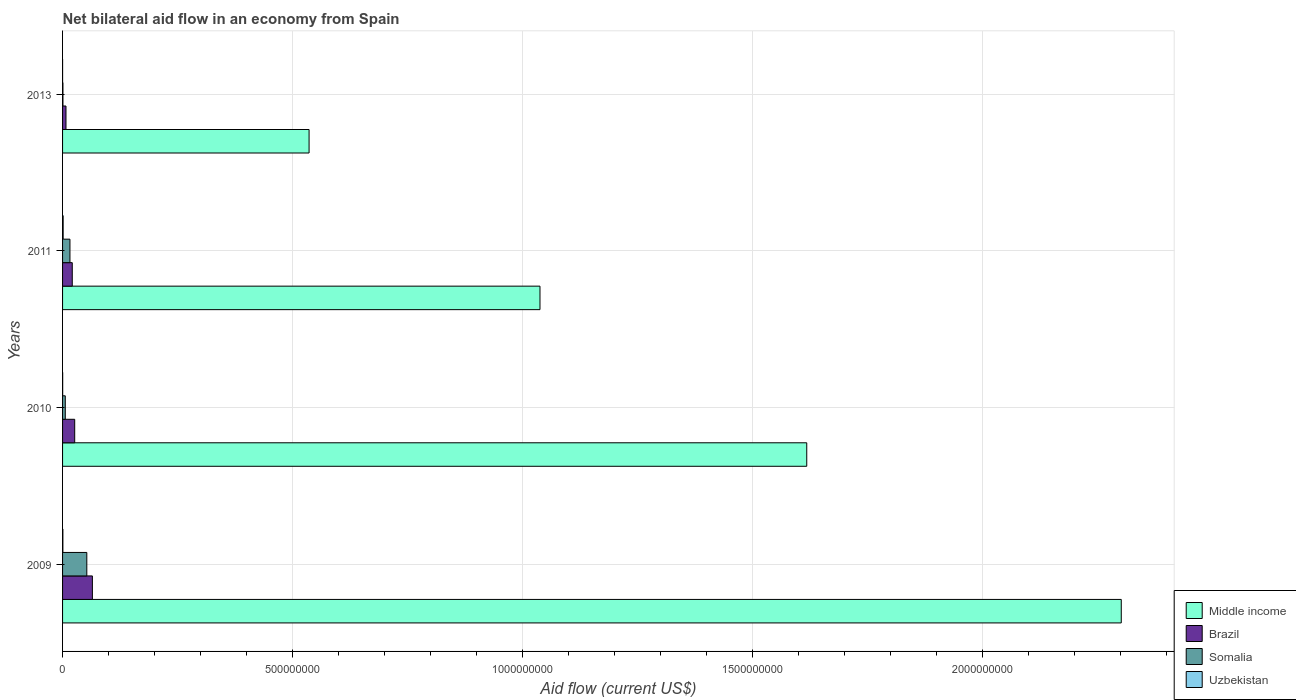How many bars are there on the 3rd tick from the top?
Your answer should be compact. 4. What is the net bilateral aid flow in Middle income in 2009?
Give a very brief answer. 2.30e+09. Across all years, what is the maximum net bilateral aid flow in Uzbekistan?
Offer a very short reply. 1.27e+06. Across all years, what is the minimum net bilateral aid flow in Brazil?
Offer a very short reply. 7.44e+06. In which year was the net bilateral aid flow in Uzbekistan maximum?
Provide a succinct answer. 2011. What is the total net bilateral aid flow in Uzbekistan in the graph?
Offer a terse response. 2.19e+06. What is the difference between the net bilateral aid flow in Middle income in 2009 and that in 2010?
Give a very brief answer. 6.84e+08. What is the difference between the net bilateral aid flow in Somalia in 2010 and the net bilateral aid flow in Brazil in 2009?
Offer a very short reply. -5.90e+07. What is the average net bilateral aid flow in Somalia per year?
Offer a terse response. 1.89e+07. In the year 2011, what is the difference between the net bilateral aid flow in Uzbekistan and net bilateral aid flow in Somalia?
Provide a short and direct response. -1.48e+07. In how many years, is the net bilateral aid flow in Brazil greater than 2000000000 US$?
Your answer should be very brief. 0. What is the ratio of the net bilateral aid flow in Middle income in 2009 to that in 2013?
Your response must be concise. 4.29. What is the difference between the highest and the second highest net bilateral aid flow in Somalia?
Offer a terse response. 3.67e+07. What is the difference between the highest and the lowest net bilateral aid flow in Brazil?
Make the answer very short. 5.74e+07. In how many years, is the net bilateral aid flow in Somalia greater than the average net bilateral aid flow in Somalia taken over all years?
Make the answer very short. 1. Is the sum of the net bilateral aid flow in Somalia in 2011 and 2013 greater than the maximum net bilateral aid flow in Middle income across all years?
Ensure brevity in your answer.  No. Is it the case that in every year, the sum of the net bilateral aid flow in Brazil and net bilateral aid flow in Middle income is greater than the sum of net bilateral aid flow in Uzbekistan and net bilateral aid flow in Somalia?
Offer a terse response. Yes. What does the 3rd bar from the bottom in 2013 represents?
Your answer should be very brief. Somalia. Is it the case that in every year, the sum of the net bilateral aid flow in Somalia and net bilateral aid flow in Uzbekistan is greater than the net bilateral aid flow in Brazil?
Offer a very short reply. No. Are all the bars in the graph horizontal?
Give a very brief answer. Yes. What is the difference between two consecutive major ticks on the X-axis?
Your answer should be very brief. 5.00e+08. Are the values on the major ticks of X-axis written in scientific E-notation?
Provide a succinct answer. No. Does the graph contain any zero values?
Make the answer very short. No. How many legend labels are there?
Your answer should be very brief. 4. How are the legend labels stacked?
Your response must be concise. Vertical. What is the title of the graph?
Offer a very short reply. Net bilateral aid flow in an economy from Spain. What is the label or title of the X-axis?
Your answer should be very brief. Aid flow (current US$). What is the label or title of the Y-axis?
Your response must be concise. Years. What is the Aid flow (current US$) of Middle income in 2009?
Your answer should be compact. 2.30e+09. What is the Aid flow (current US$) in Brazil in 2009?
Your answer should be very brief. 6.49e+07. What is the Aid flow (current US$) in Somalia in 2009?
Offer a very short reply. 5.28e+07. What is the Aid flow (current US$) of Middle income in 2010?
Your answer should be very brief. 1.62e+09. What is the Aid flow (current US$) of Brazil in 2010?
Give a very brief answer. 2.64e+07. What is the Aid flow (current US$) in Somalia in 2010?
Make the answer very short. 5.89e+06. What is the Aid flow (current US$) in Middle income in 2011?
Offer a terse response. 1.04e+09. What is the Aid flow (current US$) of Brazil in 2011?
Your response must be concise. 2.11e+07. What is the Aid flow (current US$) of Somalia in 2011?
Offer a very short reply. 1.60e+07. What is the Aid flow (current US$) of Uzbekistan in 2011?
Your answer should be compact. 1.27e+06. What is the Aid flow (current US$) of Middle income in 2013?
Provide a short and direct response. 5.36e+08. What is the Aid flow (current US$) in Brazil in 2013?
Offer a terse response. 7.44e+06. What is the Aid flow (current US$) of Somalia in 2013?
Keep it short and to the point. 8.10e+05. Across all years, what is the maximum Aid flow (current US$) in Middle income?
Give a very brief answer. 2.30e+09. Across all years, what is the maximum Aid flow (current US$) of Brazil?
Your answer should be compact. 6.49e+07. Across all years, what is the maximum Aid flow (current US$) in Somalia?
Provide a succinct answer. 5.28e+07. Across all years, what is the maximum Aid flow (current US$) of Uzbekistan?
Provide a succinct answer. 1.27e+06. Across all years, what is the minimum Aid flow (current US$) of Middle income?
Make the answer very short. 5.36e+08. Across all years, what is the minimum Aid flow (current US$) of Brazil?
Ensure brevity in your answer.  7.44e+06. Across all years, what is the minimum Aid flow (current US$) of Somalia?
Your response must be concise. 8.10e+05. Across all years, what is the minimum Aid flow (current US$) of Uzbekistan?
Ensure brevity in your answer.  3.00e+04. What is the total Aid flow (current US$) in Middle income in the graph?
Make the answer very short. 5.50e+09. What is the total Aid flow (current US$) of Brazil in the graph?
Keep it short and to the point. 1.20e+08. What is the total Aid flow (current US$) in Somalia in the graph?
Ensure brevity in your answer.  7.55e+07. What is the total Aid flow (current US$) in Uzbekistan in the graph?
Provide a short and direct response. 2.19e+06. What is the difference between the Aid flow (current US$) of Middle income in 2009 and that in 2010?
Make the answer very short. 6.84e+08. What is the difference between the Aid flow (current US$) in Brazil in 2009 and that in 2010?
Keep it short and to the point. 3.85e+07. What is the difference between the Aid flow (current US$) in Somalia in 2009 and that in 2010?
Your answer should be compact. 4.69e+07. What is the difference between the Aid flow (current US$) in Middle income in 2009 and that in 2011?
Give a very brief answer. 1.26e+09. What is the difference between the Aid flow (current US$) in Brazil in 2009 and that in 2011?
Make the answer very short. 4.38e+07. What is the difference between the Aid flow (current US$) of Somalia in 2009 and that in 2011?
Offer a terse response. 3.67e+07. What is the difference between the Aid flow (current US$) of Uzbekistan in 2009 and that in 2011?
Provide a short and direct response. -6.10e+05. What is the difference between the Aid flow (current US$) in Middle income in 2009 and that in 2013?
Offer a very short reply. 1.77e+09. What is the difference between the Aid flow (current US$) of Brazil in 2009 and that in 2013?
Ensure brevity in your answer.  5.74e+07. What is the difference between the Aid flow (current US$) of Somalia in 2009 and that in 2013?
Your response must be concise. 5.19e+07. What is the difference between the Aid flow (current US$) in Uzbekistan in 2009 and that in 2013?
Offer a very short reply. 6.30e+05. What is the difference between the Aid flow (current US$) of Middle income in 2010 and that in 2011?
Your response must be concise. 5.80e+08. What is the difference between the Aid flow (current US$) of Brazil in 2010 and that in 2011?
Offer a terse response. 5.29e+06. What is the difference between the Aid flow (current US$) of Somalia in 2010 and that in 2011?
Provide a succinct answer. -1.02e+07. What is the difference between the Aid flow (current US$) of Uzbekistan in 2010 and that in 2011?
Offer a terse response. -1.04e+06. What is the difference between the Aid flow (current US$) in Middle income in 2010 and that in 2013?
Ensure brevity in your answer.  1.08e+09. What is the difference between the Aid flow (current US$) in Brazil in 2010 and that in 2013?
Ensure brevity in your answer.  1.90e+07. What is the difference between the Aid flow (current US$) of Somalia in 2010 and that in 2013?
Make the answer very short. 5.08e+06. What is the difference between the Aid flow (current US$) of Middle income in 2011 and that in 2013?
Offer a terse response. 5.02e+08. What is the difference between the Aid flow (current US$) in Brazil in 2011 and that in 2013?
Your response must be concise. 1.37e+07. What is the difference between the Aid flow (current US$) in Somalia in 2011 and that in 2013?
Your answer should be compact. 1.52e+07. What is the difference between the Aid flow (current US$) of Uzbekistan in 2011 and that in 2013?
Your answer should be very brief. 1.24e+06. What is the difference between the Aid flow (current US$) of Middle income in 2009 and the Aid flow (current US$) of Brazil in 2010?
Offer a terse response. 2.28e+09. What is the difference between the Aid flow (current US$) in Middle income in 2009 and the Aid flow (current US$) in Somalia in 2010?
Your response must be concise. 2.30e+09. What is the difference between the Aid flow (current US$) in Middle income in 2009 and the Aid flow (current US$) in Uzbekistan in 2010?
Make the answer very short. 2.30e+09. What is the difference between the Aid flow (current US$) in Brazil in 2009 and the Aid flow (current US$) in Somalia in 2010?
Provide a short and direct response. 5.90e+07. What is the difference between the Aid flow (current US$) in Brazil in 2009 and the Aid flow (current US$) in Uzbekistan in 2010?
Your response must be concise. 6.46e+07. What is the difference between the Aid flow (current US$) in Somalia in 2009 and the Aid flow (current US$) in Uzbekistan in 2010?
Make the answer very short. 5.25e+07. What is the difference between the Aid flow (current US$) in Middle income in 2009 and the Aid flow (current US$) in Brazil in 2011?
Provide a succinct answer. 2.28e+09. What is the difference between the Aid flow (current US$) of Middle income in 2009 and the Aid flow (current US$) of Somalia in 2011?
Provide a succinct answer. 2.29e+09. What is the difference between the Aid flow (current US$) in Middle income in 2009 and the Aid flow (current US$) in Uzbekistan in 2011?
Offer a terse response. 2.30e+09. What is the difference between the Aid flow (current US$) in Brazil in 2009 and the Aid flow (current US$) in Somalia in 2011?
Offer a very short reply. 4.88e+07. What is the difference between the Aid flow (current US$) of Brazil in 2009 and the Aid flow (current US$) of Uzbekistan in 2011?
Your answer should be very brief. 6.36e+07. What is the difference between the Aid flow (current US$) in Somalia in 2009 and the Aid flow (current US$) in Uzbekistan in 2011?
Offer a very short reply. 5.15e+07. What is the difference between the Aid flow (current US$) of Middle income in 2009 and the Aid flow (current US$) of Brazil in 2013?
Provide a succinct answer. 2.30e+09. What is the difference between the Aid flow (current US$) in Middle income in 2009 and the Aid flow (current US$) in Somalia in 2013?
Your response must be concise. 2.30e+09. What is the difference between the Aid flow (current US$) of Middle income in 2009 and the Aid flow (current US$) of Uzbekistan in 2013?
Give a very brief answer. 2.30e+09. What is the difference between the Aid flow (current US$) in Brazil in 2009 and the Aid flow (current US$) in Somalia in 2013?
Keep it short and to the point. 6.41e+07. What is the difference between the Aid flow (current US$) of Brazil in 2009 and the Aid flow (current US$) of Uzbekistan in 2013?
Make the answer very short. 6.48e+07. What is the difference between the Aid flow (current US$) of Somalia in 2009 and the Aid flow (current US$) of Uzbekistan in 2013?
Provide a short and direct response. 5.27e+07. What is the difference between the Aid flow (current US$) in Middle income in 2010 and the Aid flow (current US$) in Brazil in 2011?
Your answer should be very brief. 1.60e+09. What is the difference between the Aid flow (current US$) of Middle income in 2010 and the Aid flow (current US$) of Somalia in 2011?
Your answer should be very brief. 1.60e+09. What is the difference between the Aid flow (current US$) in Middle income in 2010 and the Aid flow (current US$) in Uzbekistan in 2011?
Provide a short and direct response. 1.62e+09. What is the difference between the Aid flow (current US$) in Brazil in 2010 and the Aid flow (current US$) in Somalia in 2011?
Give a very brief answer. 1.03e+07. What is the difference between the Aid flow (current US$) in Brazil in 2010 and the Aid flow (current US$) in Uzbekistan in 2011?
Keep it short and to the point. 2.51e+07. What is the difference between the Aid flow (current US$) of Somalia in 2010 and the Aid flow (current US$) of Uzbekistan in 2011?
Your response must be concise. 4.62e+06. What is the difference between the Aid flow (current US$) of Middle income in 2010 and the Aid flow (current US$) of Brazil in 2013?
Ensure brevity in your answer.  1.61e+09. What is the difference between the Aid flow (current US$) of Middle income in 2010 and the Aid flow (current US$) of Somalia in 2013?
Ensure brevity in your answer.  1.62e+09. What is the difference between the Aid flow (current US$) in Middle income in 2010 and the Aid flow (current US$) in Uzbekistan in 2013?
Provide a succinct answer. 1.62e+09. What is the difference between the Aid flow (current US$) of Brazil in 2010 and the Aid flow (current US$) of Somalia in 2013?
Provide a succinct answer. 2.56e+07. What is the difference between the Aid flow (current US$) in Brazil in 2010 and the Aid flow (current US$) in Uzbekistan in 2013?
Your answer should be very brief. 2.64e+07. What is the difference between the Aid flow (current US$) of Somalia in 2010 and the Aid flow (current US$) of Uzbekistan in 2013?
Give a very brief answer. 5.86e+06. What is the difference between the Aid flow (current US$) in Middle income in 2011 and the Aid flow (current US$) in Brazil in 2013?
Keep it short and to the point. 1.03e+09. What is the difference between the Aid flow (current US$) of Middle income in 2011 and the Aid flow (current US$) of Somalia in 2013?
Your answer should be very brief. 1.04e+09. What is the difference between the Aid flow (current US$) of Middle income in 2011 and the Aid flow (current US$) of Uzbekistan in 2013?
Your answer should be compact. 1.04e+09. What is the difference between the Aid flow (current US$) of Brazil in 2011 and the Aid flow (current US$) of Somalia in 2013?
Ensure brevity in your answer.  2.03e+07. What is the difference between the Aid flow (current US$) of Brazil in 2011 and the Aid flow (current US$) of Uzbekistan in 2013?
Your answer should be compact. 2.11e+07. What is the difference between the Aid flow (current US$) in Somalia in 2011 and the Aid flow (current US$) in Uzbekistan in 2013?
Provide a short and direct response. 1.60e+07. What is the average Aid flow (current US$) in Middle income per year?
Provide a succinct answer. 1.37e+09. What is the average Aid flow (current US$) of Brazil per year?
Your answer should be compact. 3.00e+07. What is the average Aid flow (current US$) of Somalia per year?
Ensure brevity in your answer.  1.89e+07. What is the average Aid flow (current US$) of Uzbekistan per year?
Provide a short and direct response. 5.48e+05. In the year 2009, what is the difference between the Aid flow (current US$) of Middle income and Aid flow (current US$) of Brazil?
Give a very brief answer. 2.24e+09. In the year 2009, what is the difference between the Aid flow (current US$) of Middle income and Aid flow (current US$) of Somalia?
Give a very brief answer. 2.25e+09. In the year 2009, what is the difference between the Aid flow (current US$) in Middle income and Aid flow (current US$) in Uzbekistan?
Make the answer very short. 2.30e+09. In the year 2009, what is the difference between the Aid flow (current US$) in Brazil and Aid flow (current US$) in Somalia?
Offer a very short reply. 1.21e+07. In the year 2009, what is the difference between the Aid flow (current US$) in Brazil and Aid flow (current US$) in Uzbekistan?
Your answer should be compact. 6.42e+07. In the year 2009, what is the difference between the Aid flow (current US$) of Somalia and Aid flow (current US$) of Uzbekistan?
Your answer should be compact. 5.21e+07. In the year 2010, what is the difference between the Aid flow (current US$) in Middle income and Aid flow (current US$) in Brazil?
Your answer should be compact. 1.59e+09. In the year 2010, what is the difference between the Aid flow (current US$) in Middle income and Aid flow (current US$) in Somalia?
Give a very brief answer. 1.61e+09. In the year 2010, what is the difference between the Aid flow (current US$) in Middle income and Aid flow (current US$) in Uzbekistan?
Ensure brevity in your answer.  1.62e+09. In the year 2010, what is the difference between the Aid flow (current US$) of Brazil and Aid flow (current US$) of Somalia?
Give a very brief answer. 2.05e+07. In the year 2010, what is the difference between the Aid flow (current US$) of Brazil and Aid flow (current US$) of Uzbekistan?
Your answer should be compact. 2.62e+07. In the year 2010, what is the difference between the Aid flow (current US$) in Somalia and Aid flow (current US$) in Uzbekistan?
Your answer should be compact. 5.66e+06. In the year 2011, what is the difference between the Aid flow (current US$) of Middle income and Aid flow (current US$) of Brazil?
Your response must be concise. 1.02e+09. In the year 2011, what is the difference between the Aid flow (current US$) in Middle income and Aid flow (current US$) in Somalia?
Make the answer very short. 1.02e+09. In the year 2011, what is the difference between the Aid flow (current US$) of Middle income and Aid flow (current US$) of Uzbekistan?
Offer a very short reply. 1.04e+09. In the year 2011, what is the difference between the Aid flow (current US$) of Brazil and Aid flow (current US$) of Somalia?
Provide a short and direct response. 5.05e+06. In the year 2011, what is the difference between the Aid flow (current US$) of Brazil and Aid flow (current US$) of Uzbekistan?
Provide a succinct answer. 1.98e+07. In the year 2011, what is the difference between the Aid flow (current US$) in Somalia and Aid flow (current US$) in Uzbekistan?
Provide a succinct answer. 1.48e+07. In the year 2013, what is the difference between the Aid flow (current US$) of Middle income and Aid flow (current US$) of Brazil?
Give a very brief answer. 5.29e+08. In the year 2013, what is the difference between the Aid flow (current US$) of Middle income and Aid flow (current US$) of Somalia?
Provide a short and direct response. 5.35e+08. In the year 2013, what is the difference between the Aid flow (current US$) of Middle income and Aid flow (current US$) of Uzbekistan?
Ensure brevity in your answer.  5.36e+08. In the year 2013, what is the difference between the Aid flow (current US$) of Brazil and Aid flow (current US$) of Somalia?
Give a very brief answer. 6.63e+06. In the year 2013, what is the difference between the Aid flow (current US$) of Brazil and Aid flow (current US$) of Uzbekistan?
Keep it short and to the point. 7.41e+06. In the year 2013, what is the difference between the Aid flow (current US$) of Somalia and Aid flow (current US$) of Uzbekistan?
Offer a very short reply. 7.80e+05. What is the ratio of the Aid flow (current US$) in Middle income in 2009 to that in 2010?
Offer a very short reply. 1.42. What is the ratio of the Aid flow (current US$) in Brazil in 2009 to that in 2010?
Keep it short and to the point. 2.46. What is the ratio of the Aid flow (current US$) of Somalia in 2009 to that in 2010?
Provide a succinct answer. 8.96. What is the ratio of the Aid flow (current US$) of Uzbekistan in 2009 to that in 2010?
Give a very brief answer. 2.87. What is the ratio of the Aid flow (current US$) of Middle income in 2009 to that in 2011?
Give a very brief answer. 2.22. What is the ratio of the Aid flow (current US$) in Brazil in 2009 to that in 2011?
Ensure brevity in your answer.  3.07. What is the ratio of the Aid flow (current US$) of Somalia in 2009 to that in 2011?
Your response must be concise. 3.29. What is the ratio of the Aid flow (current US$) of Uzbekistan in 2009 to that in 2011?
Your answer should be compact. 0.52. What is the ratio of the Aid flow (current US$) in Middle income in 2009 to that in 2013?
Your answer should be very brief. 4.29. What is the ratio of the Aid flow (current US$) in Brazil in 2009 to that in 2013?
Make the answer very short. 8.72. What is the ratio of the Aid flow (current US$) in Somalia in 2009 to that in 2013?
Keep it short and to the point. 65.12. What is the ratio of the Aid flow (current US$) of Uzbekistan in 2009 to that in 2013?
Offer a terse response. 22. What is the ratio of the Aid flow (current US$) of Middle income in 2010 to that in 2011?
Give a very brief answer. 1.56. What is the ratio of the Aid flow (current US$) of Brazil in 2010 to that in 2011?
Your answer should be compact. 1.25. What is the ratio of the Aid flow (current US$) in Somalia in 2010 to that in 2011?
Give a very brief answer. 0.37. What is the ratio of the Aid flow (current US$) of Uzbekistan in 2010 to that in 2011?
Give a very brief answer. 0.18. What is the ratio of the Aid flow (current US$) of Middle income in 2010 to that in 2013?
Offer a very short reply. 3.02. What is the ratio of the Aid flow (current US$) in Brazil in 2010 to that in 2013?
Give a very brief answer. 3.55. What is the ratio of the Aid flow (current US$) of Somalia in 2010 to that in 2013?
Offer a terse response. 7.27. What is the ratio of the Aid flow (current US$) of Uzbekistan in 2010 to that in 2013?
Offer a terse response. 7.67. What is the ratio of the Aid flow (current US$) in Middle income in 2011 to that in 2013?
Your answer should be very brief. 1.94. What is the ratio of the Aid flow (current US$) of Brazil in 2011 to that in 2013?
Give a very brief answer. 2.84. What is the ratio of the Aid flow (current US$) in Somalia in 2011 to that in 2013?
Provide a succinct answer. 19.81. What is the ratio of the Aid flow (current US$) of Uzbekistan in 2011 to that in 2013?
Give a very brief answer. 42.33. What is the difference between the highest and the second highest Aid flow (current US$) of Middle income?
Your response must be concise. 6.84e+08. What is the difference between the highest and the second highest Aid flow (current US$) of Brazil?
Provide a short and direct response. 3.85e+07. What is the difference between the highest and the second highest Aid flow (current US$) in Somalia?
Keep it short and to the point. 3.67e+07. What is the difference between the highest and the lowest Aid flow (current US$) of Middle income?
Provide a short and direct response. 1.77e+09. What is the difference between the highest and the lowest Aid flow (current US$) in Brazil?
Provide a succinct answer. 5.74e+07. What is the difference between the highest and the lowest Aid flow (current US$) of Somalia?
Provide a short and direct response. 5.19e+07. What is the difference between the highest and the lowest Aid flow (current US$) of Uzbekistan?
Your response must be concise. 1.24e+06. 